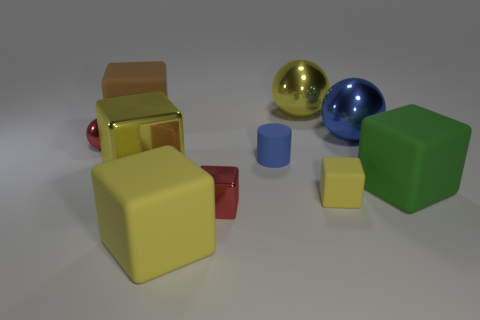Subtract all red spheres. How many yellow blocks are left? 3 Subtract all yellow matte cubes. How many cubes are left? 4 Subtract all yellow blocks. How many blocks are left? 3 Subtract 1 spheres. How many spheres are left? 2 Subtract all spheres. How many objects are left? 7 Subtract all cyan balls. Subtract all green blocks. How many balls are left? 3 Subtract all blue things. Subtract all big brown rubber blocks. How many objects are left? 7 Add 5 tiny metallic objects. How many tiny metallic objects are left? 7 Add 5 yellow metal cylinders. How many yellow metal cylinders exist? 5 Subtract 0 cyan cylinders. How many objects are left? 10 